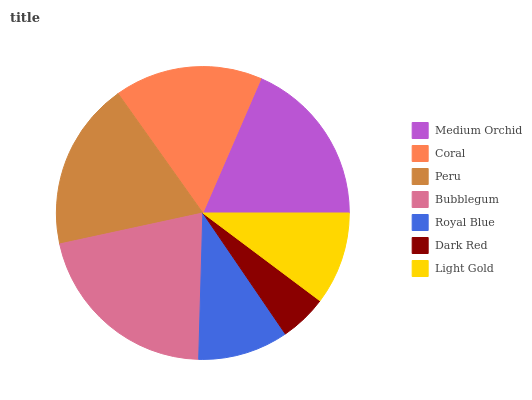Is Dark Red the minimum?
Answer yes or no. Yes. Is Bubblegum the maximum?
Answer yes or no. Yes. Is Coral the minimum?
Answer yes or no. No. Is Coral the maximum?
Answer yes or no. No. Is Medium Orchid greater than Coral?
Answer yes or no. Yes. Is Coral less than Medium Orchid?
Answer yes or no. Yes. Is Coral greater than Medium Orchid?
Answer yes or no. No. Is Medium Orchid less than Coral?
Answer yes or no. No. Is Coral the high median?
Answer yes or no. Yes. Is Coral the low median?
Answer yes or no. Yes. Is Peru the high median?
Answer yes or no. No. Is Medium Orchid the low median?
Answer yes or no. No. 